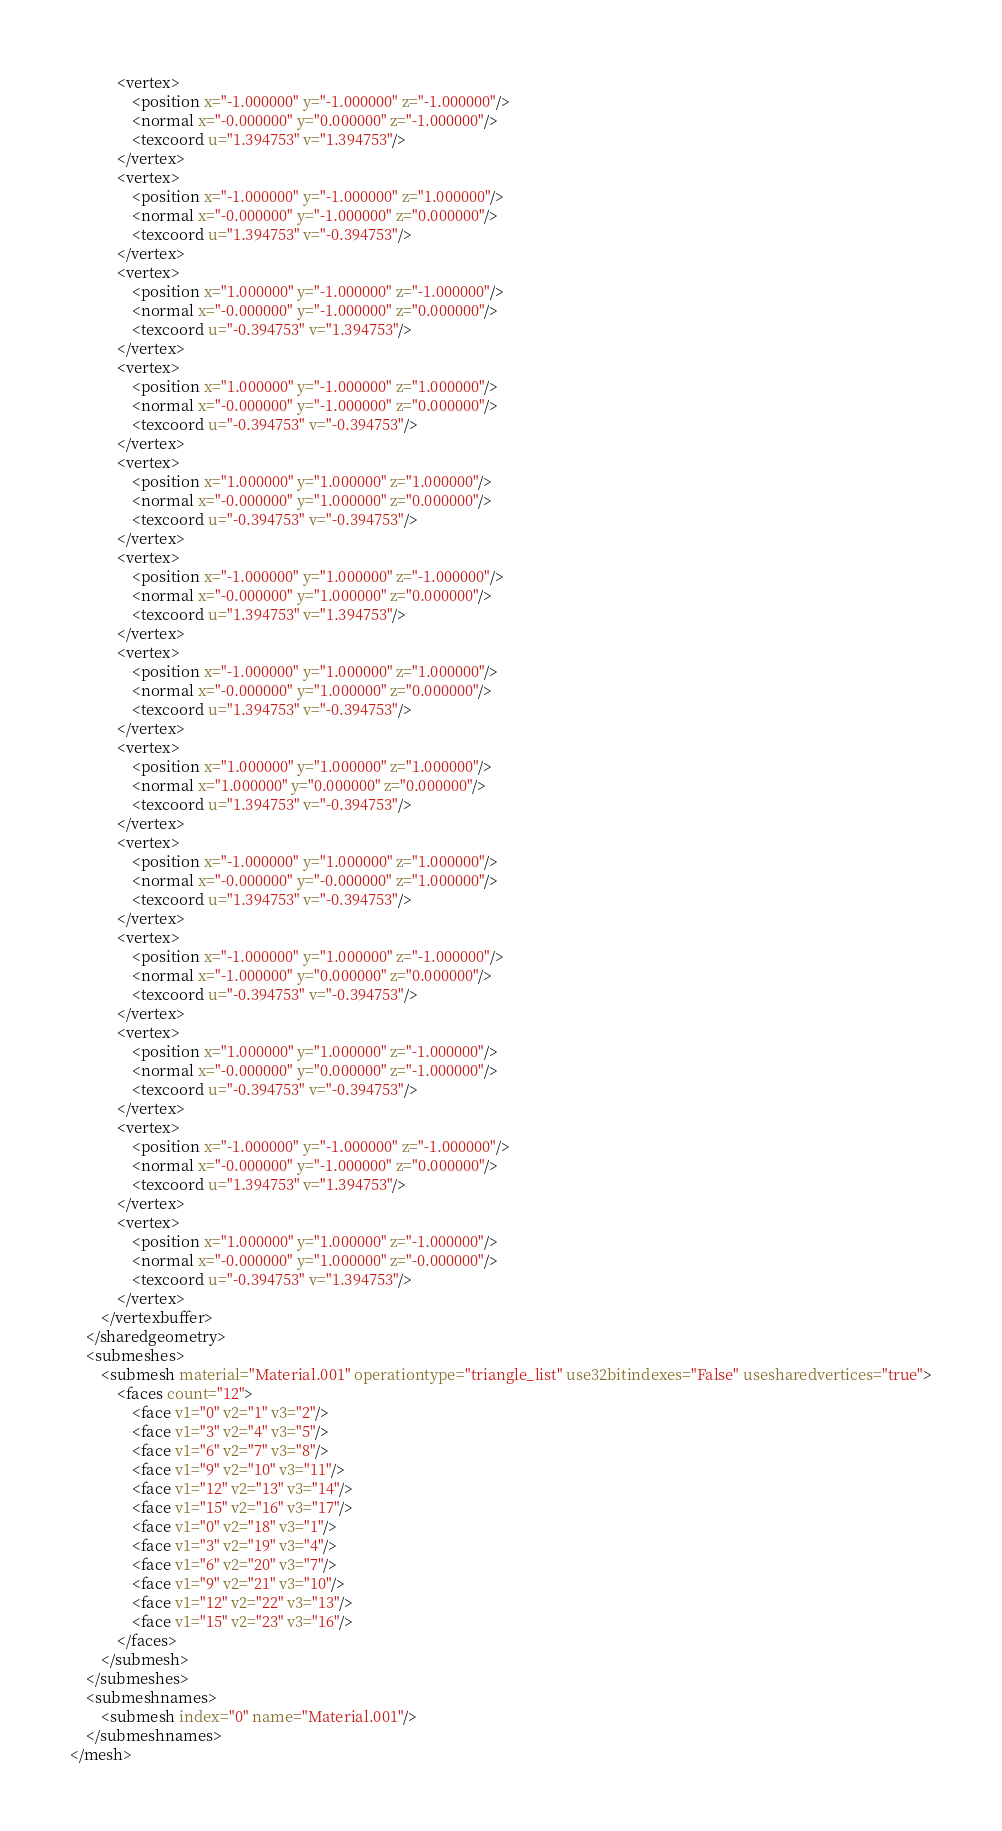<code> <loc_0><loc_0><loc_500><loc_500><_XML_>            <vertex>
                <position x="-1.000000" y="-1.000000" z="-1.000000"/>
                <normal x="-0.000000" y="0.000000" z="-1.000000"/>
                <texcoord u="1.394753" v="1.394753"/>
            </vertex>
            <vertex>
                <position x="-1.000000" y="-1.000000" z="1.000000"/>
                <normal x="-0.000000" y="-1.000000" z="0.000000"/>
                <texcoord u="1.394753" v="-0.394753"/>
            </vertex>
            <vertex>
                <position x="1.000000" y="-1.000000" z="-1.000000"/>
                <normal x="-0.000000" y="-1.000000" z="0.000000"/>
                <texcoord u="-0.394753" v="1.394753"/>
            </vertex>
            <vertex>
                <position x="1.000000" y="-1.000000" z="1.000000"/>
                <normal x="-0.000000" y="-1.000000" z="0.000000"/>
                <texcoord u="-0.394753" v="-0.394753"/>
            </vertex>
            <vertex>
                <position x="1.000000" y="1.000000" z="1.000000"/>
                <normal x="-0.000000" y="1.000000" z="0.000000"/>
                <texcoord u="-0.394753" v="-0.394753"/>
            </vertex>
            <vertex>
                <position x="-1.000000" y="1.000000" z="-1.000000"/>
                <normal x="-0.000000" y="1.000000" z="0.000000"/>
                <texcoord u="1.394753" v="1.394753"/>
            </vertex>
            <vertex>
                <position x="-1.000000" y="1.000000" z="1.000000"/>
                <normal x="-0.000000" y="1.000000" z="0.000000"/>
                <texcoord u="1.394753" v="-0.394753"/>
            </vertex>
            <vertex>
                <position x="1.000000" y="1.000000" z="1.000000"/>
                <normal x="1.000000" y="0.000000" z="0.000000"/>
                <texcoord u="1.394753" v="-0.394753"/>
            </vertex>
            <vertex>
                <position x="-1.000000" y="1.000000" z="1.000000"/>
                <normal x="-0.000000" y="-0.000000" z="1.000000"/>
                <texcoord u="1.394753" v="-0.394753"/>
            </vertex>
            <vertex>
                <position x="-1.000000" y="1.000000" z="-1.000000"/>
                <normal x="-1.000000" y="0.000000" z="0.000000"/>
                <texcoord u="-0.394753" v="-0.394753"/>
            </vertex>
            <vertex>
                <position x="1.000000" y="1.000000" z="-1.000000"/>
                <normal x="-0.000000" y="0.000000" z="-1.000000"/>
                <texcoord u="-0.394753" v="-0.394753"/>
            </vertex>
            <vertex>
                <position x="-1.000000" y="-1.000000" z="-1.000000"/>
                <normal x="-0.000000" y="-1.000000" z="0.000000"/>
                <texcoord u="1.394753" v="1.394753"/>
            </vertex>
            <vertex>
                <position x="1.000000" y="1.000000" z="-1.000000"/>
                <normal x="-0.000000" y="1.000000" z="-0.000000"/>
                <texcoord u="-0.394753" v="1.394753"/>
            </vertex>
        </vertexbuffer>
    </sharedgeometry>
    <submeshes>
        <submesh material="Material.001" operationtype="triangle_list" use32bitindexes="False" usesharedvertices="true">
            <faces count="12">
                <face v1="0" v2="1" v3="2"/>
                <face v1="3" v2="4" v3="5"/>
                <face v1="6" v2="7" v3="8"/>
                <face v1="9" v2="10" v3="11"/>
                <face v1="12" v2="13" v3="14"/>
                <face v1="15" v2="16" v3="17"/>
                <face v1="0" v2="18" v3="1"/>
                <face v1="3" v2="19" v3="4"/>
                <face v1="6" v2="20" v3="7"/>
                <face v1="9" v2="21" v3="10"/>
                <face v1="12" v2="22" v3="13"/>
                <face v1="15" v2="23" v3="16"/>
            </faces>
        </submesh>
    </submeshes>
    <submeshnames>
        <submesh index="0" name="Material.001"/>
    </submeshnames>
</mesh>
</code> 